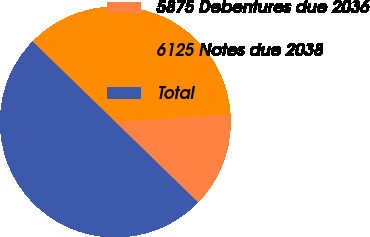<chart> <loc_0><loc_0><loc_500><loc_500><pie_chart><fcel>5875 Debentures due 2036<fcel>6125 Notes due 2038<fcel>Total<nl><fcel>13.33%<fcel>36.67%<fcel>50.0%<nl></chart> 